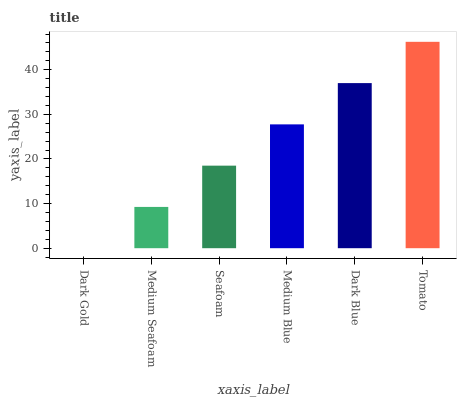Is Dark Gold the minimum?
Answer yes or no. Yes. Is Tomato the maximum?
Answer yes or no. Yes. Is Medium Seafoam the minimum?
Answer yes or no. No. Is Medium Seafoam the maximum?
Answer yes or no. No. Is Medium Seafoam greater than Dark Gold?
Answer yes or no. Yes. Is Dark Gold less than Medium Seafoam?
Answer yes or no. Yes. Is Dark Gold greater than Medium Seafoam?
Answer yes or no. No. Is Medium Seafoam less than Dark Gold?
Answer yes or no. No. Is Medium Blue the high median?
Answer yes or no. Yes. Is Seafoam the low median?
Answer yes or no. Yes. Is Medium Seafoam the high median?
Answer yes or no. No. Is Tomato the low median?
Answer yes or no. No. 